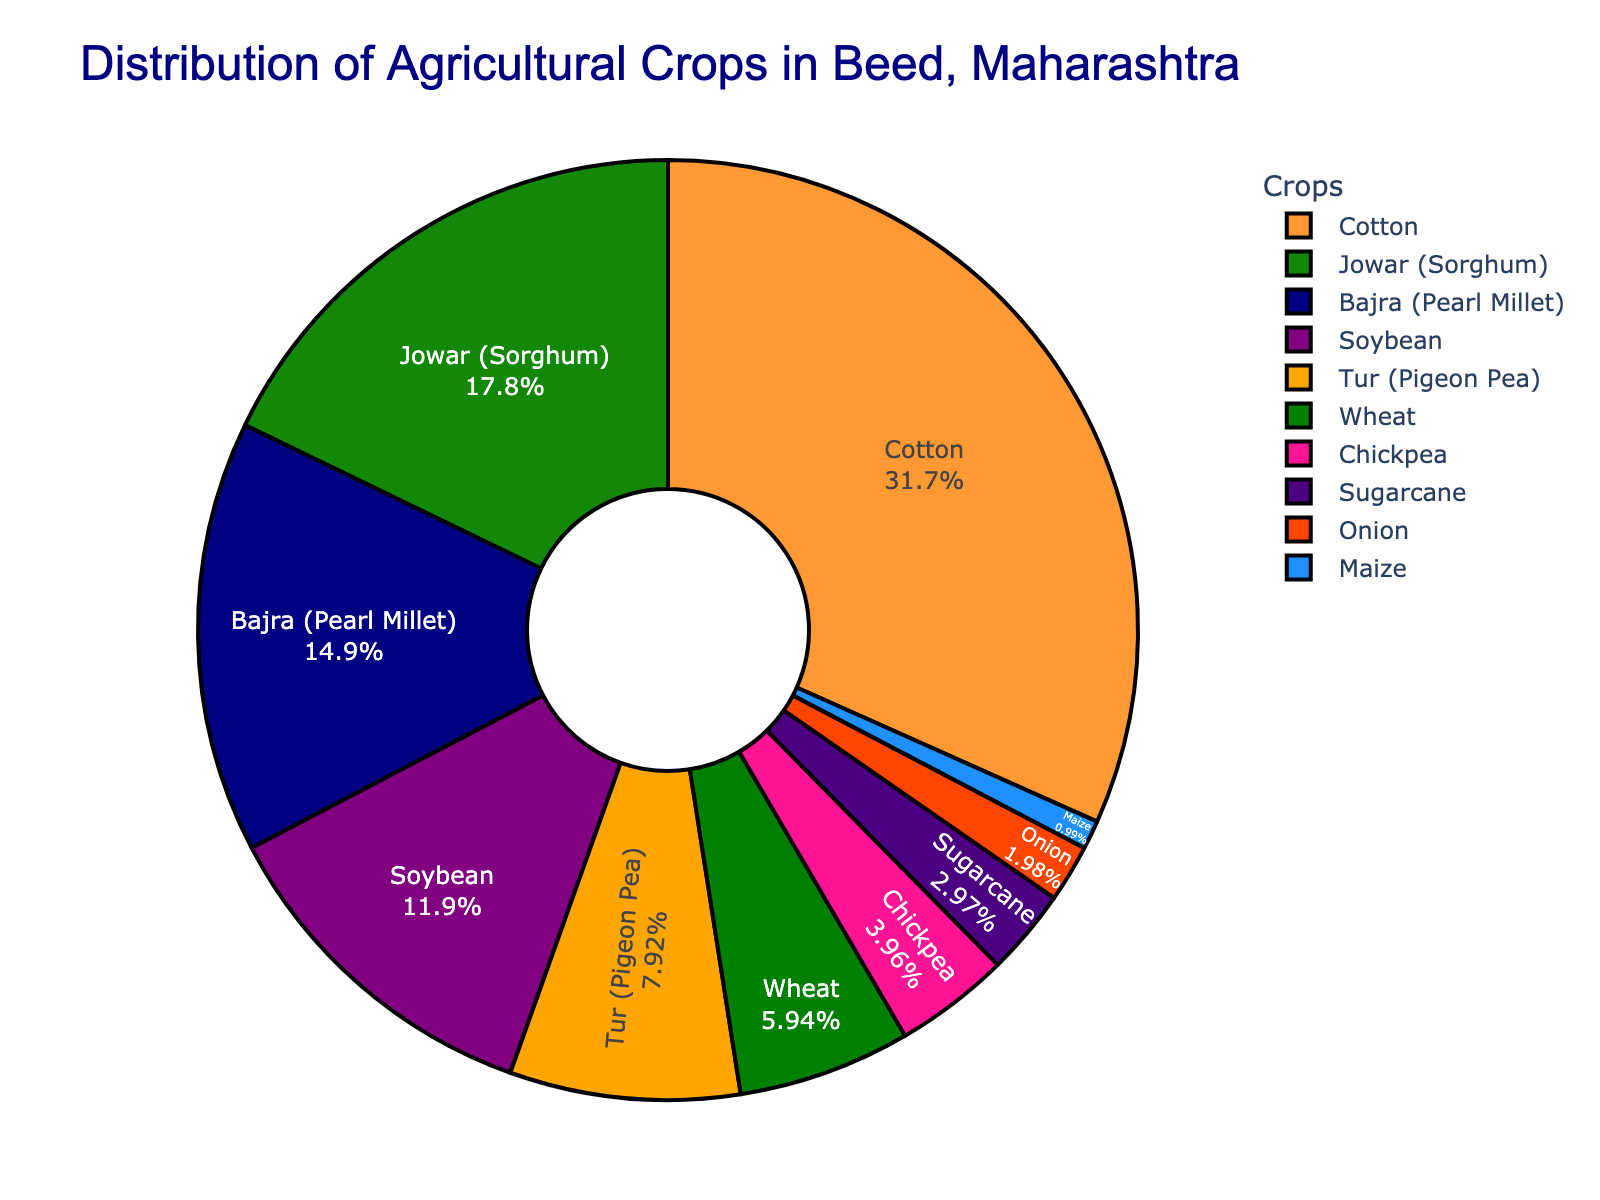What is the percentage of the most grown crop in Beed district? The figure shows the percentage distribution of different crops grown in Beed district. Observing the pie chart, the largest segment corresponds to Cotton. The text indicates Cotton occupies 32% of the total agricultural area.
Answer: 32% Which crop has the smallest cultivation area percentage-wise, and what is that percentage? The smallest segment in the pie chart is represented by Maize. The text indicates that Maize occupies only 1% of the total agricultural area.
Answer: Maize, 1% What is the combined percentage of Jowar (Sorghum) and Bajra (Pearl Millet)? To find the combined percentage, we add the percentage of Jowar (18%) and Bajra (15%). That gives us 18 + 15 = 33%.
Answer: 33% Which crops together account for more than 50% of the agricultural area? We need to find the combined percentage of the top crops until it exceeds 50%. Starting from the largest: 
Cotton (32%), Jowar (18%), and Bajra (15%). Adding them: 
32 + 18 = 50, then 50 + 15 = 65%. Thus, Cotton, Jowar, and Bajra together account for more than 50%.
Answer: Cotton, Jowar, and Bajra How many crops have a cultivation percentage greater than 10%? By observing the pie chart, the crops which have a cultivation percentage greater than 10% are Cotton (32%), Jowar (18%), Bajra (15%), and Soybean (12%). This gives us a count of 4 crops.
Answer: 4 Compare the cultivation percentage of Soybean and Wheat. Which one is higher and by how much? Soybean has a cultivation percentage of 12%, whereas Wheat has 6%. To find the difference: 
12 - 6 = 6%. Hence, Soybean is higher by 6%.
Answer: Soybean is higher by 6% If we combine the percentage of Onion, Maize, and Sugarcane, does it exceed the percentage of Tur (Pigeon Pea)? Adding the percentages of Onion (2%), Maize (1%), and Sugarcane (3%): 
2 + 1 + 3 = 6%. Tur has a percentage of 8%. Thus, the combined percentage of Onion, Maize, and Sugarcane (6%) does not exceed Tur’s (8%).
Answer: No, 6% < 8% What is the total percentage of crops cultivated other than Cotton, Jowar, Bajra, and Soybean? First find the combined percentage of Cotton, Jowar, Bajra, and Soybean: 
32% (Cotton) + 18% (Jowar) + 15% (Bajra) + 12% (Soybean) = 77%. Then, subtract from 100%:
100 - 77 = 23%. Therefore, the total percentage of other crops is 23%.
Answer: 23% Which crop is depicted using the orange color in the pie chart? By observing the color distribution in the pie chart and matching it with the labels, the orange color represents the crop Bajra (Pearl Millet).
Answer: Bajra (Pearl Millet) Is the percentage of Wheat cultivation between 5% and 10%? Referring to the pie chart, Wheat has a cultivation percentage of 6%, which indeed falls between 5% and 10%.
Answer: Yes 